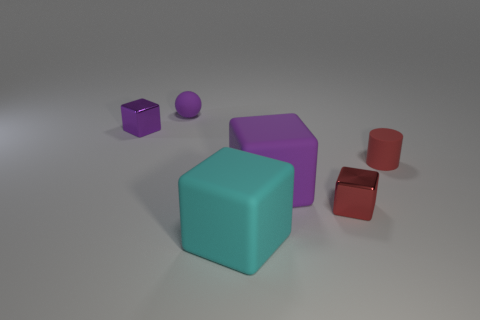How many purple cubes must be subtracted to get 1 purple cubes? 1 Subtract all purple rubber cubes. How many cubes are left? 3 Subtract all purple cubes. How many cubes are left? 2 Subtract all cylinders. How many objects are left? 5 Add 1 tiny purple shiny cubes. How many tiny purple shiny cubes exist? 2 Add 1 small blue metallic cylinders. How many objects exist? 7 Subtract 1 purple spheres. How many objects are left? 5 Subtract 2 cubes. How many cubes are left? 2 Subtract all blue cubes. Subtract all yellow cylinders. How many cubes are left? 4 Subtract all purple spheres. How many purple blocks are left? 2 